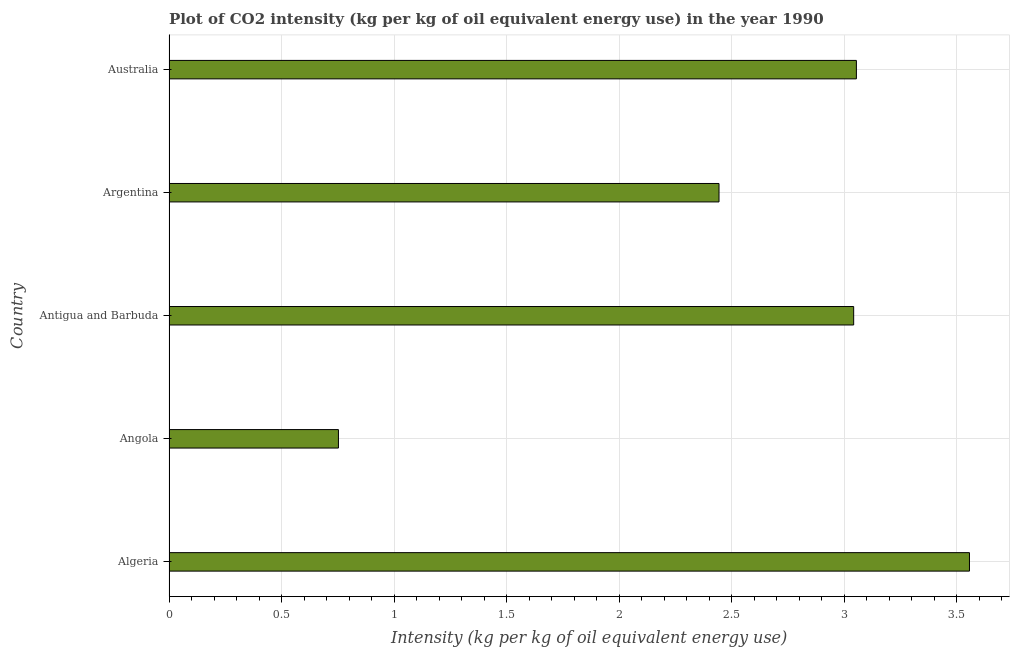Does the graph contain any zero values?
Make the answer very short. No. Does the graph contain grids?
Offer a very short reply. Yes. What is the title of the graph?
Provide a short and direct response. Plot of CO2 intensity (kg per kg of oil equivalent energy use) in the year 1990. What is the label or title of the X-axis?
Offer a terse response. Intensity (kg per kg of oil equivalent energy use). What is the co2 intensity in Algeria?
Provide a short and direct response. 3.56. Across all countries, what is the maximum co2 intensity?
Make the answer very short. 3.56. Across all countries, what is the minimum co2 intensity?
Ensure brevity in your answer.  0.75. In which country was the co2 intensity maximum?
Make the answer very short. Algeria. In which country was the co2 intensity minimum?
Your answer should be very brief. Angola. What is the sum of the co2 intensity?
Offer a terse response. 12.85. What is the difference between the co2 intensity in Antigua and Barbuda and Argentina?
Provide a short and direct response. 0.6. What is the average co2 intensity per country?
Keep it short and to the point. 2.57. What is the median co2 intensity?
Provide a short and direct response. 3.04. In how many countries, is the co2 intensity greater than 0.6 kg?
Your answer should be compact. 5. What is the ratio of the co2 intensity in Angola to that in Argentina?
Ensure brevity in your answer.  0.31. What is the difference between the highest and the second highest co2 intensity?
Ensure brevity in your answer.  0.5. How many bars are there?
Provide a succinct answer. 5. How many countries are there in the graph?
Offer a very short reply. 5. What is the difference between two consecutive major ticks on the X-axis?
Offer a very short reply. 0.5. What is the Intensity (kg per kg of oil equivalent energy use) in Algeria?
Make the answer very short. 3.56. What is the Intensity (kg per kg of oil equivalent energy use) of Angola?
Provide a short and direct response. 0.75. What is the Intensity (kg per kg of oil equivalent energy use) of Antigua and Barbuda?
Keep it short and to the point. 3.04. What is the Intensity (kg per kg of oil equivalent energy use) in Argentina?
Provide a succinct answer. 2.44. What is the Intensity (kg per kg of oil equivalent energy use) in Australia?
Provide a succinct answer. 3.05. What is the difference between the Intensity (kg per kg of oil equivalent energy use) in Algeria and Angola?
Your answer should be compact. 2.8. What is the difference between the Intensity (kg per kg of oil equivalent energy use) in Algeria and Antigua and Barbuda?
Ensure brevity in your answer.  0.51. What is the difference between the Intensity (kg per kg of oil equivalent energy use) in Algeria and Argentina?
Offer a very short reply. 1.11. What is the difference between the Intensity (kg per kg of oil equivalent energy use) in Algeria and Australia?
Give a very brief answer. 0.5. What is the difference between the Intensity (kg per kg of oil equivalent energy use) in Angola and Antigua and Barbuda?
Offer a terse response. -2.29. What is the difference between the Intensity (kg per kg of oil equivalent energy use) in Angola and Argentina?
Keep it short and to the point. -1.69. What is the difference between the Intensity (kg per kg of oil equivalent energy use) in Angola and Australia?
Keep it short and to the point. -2.3. What is the difference between the Intensity (kg per kg of oil equivalent energy use) in Antigua and Barbuda and Argentina?
Provide a succinct answer. 0.6. What is the difference between the Intensity (kg per kg of oil equivalent energy use) in Antigua and Barbuda and Australia?
Make the answer very short. -0.01. What is the difference between the Intensity (kg per kg of oil equivalent energy use) in Argentina and Australia?
Give a very brief answer. -0.61. What is the ratio of the Intensity (kg per kg of oil equivalent energy use) in Algeria to that in Angola?
Your answer should be very brief. 4.72. What is the ratio of the Intensity (kg per kg of oil equivalent energy use) in Algeria to that in Antigua and Barbuda?
Your answer should be very brief. 1.17. What is the ratio of the Intensity (kg per kg of oil equivalent energy use) in Algeria to that in Argentina?
Your response must be concise. 1.46. What is the ratio of the Intensity (kg per kg of oil equivalent energy use) in Algeria to that in Australia?
Keep it short and to the point. 1.17. What is the ratio of the Intensity (kg per kg of oil equivalent energy use) in Angola to that in Antigua and Barbuda?
Provide a short and direct response. 0.25. What is the ratio of the Intensity (kg per kg of oil equivalent energy use) in Angola to that in Argentina?
Your answer should be compact. 0.31. What is the ratio of the Intensity (kg per kg of oil equivalent energy use) in Angola to that in Australia?
Your response must be concise. 0.25. What is the ratio of the Intensity (kg per kg of oil equivalent energy use) in Antigua and Barbuda to that in Argentina?
Your response must be concise. 1.25. What is the ratio of the Intensity (kg per kg of oil equivalent energy use) in Argentina to that in Australia?
Make the answer very short. 0.8. 